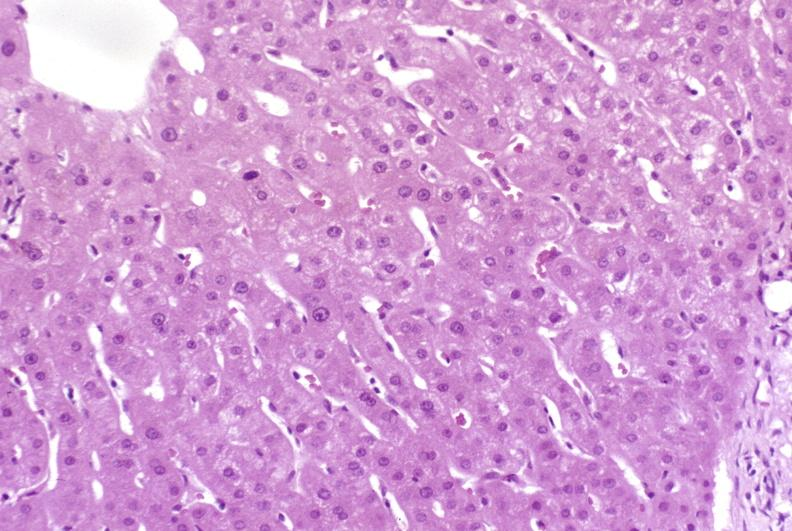s liver present?
Answer the question using a single word or phrase. Yes 